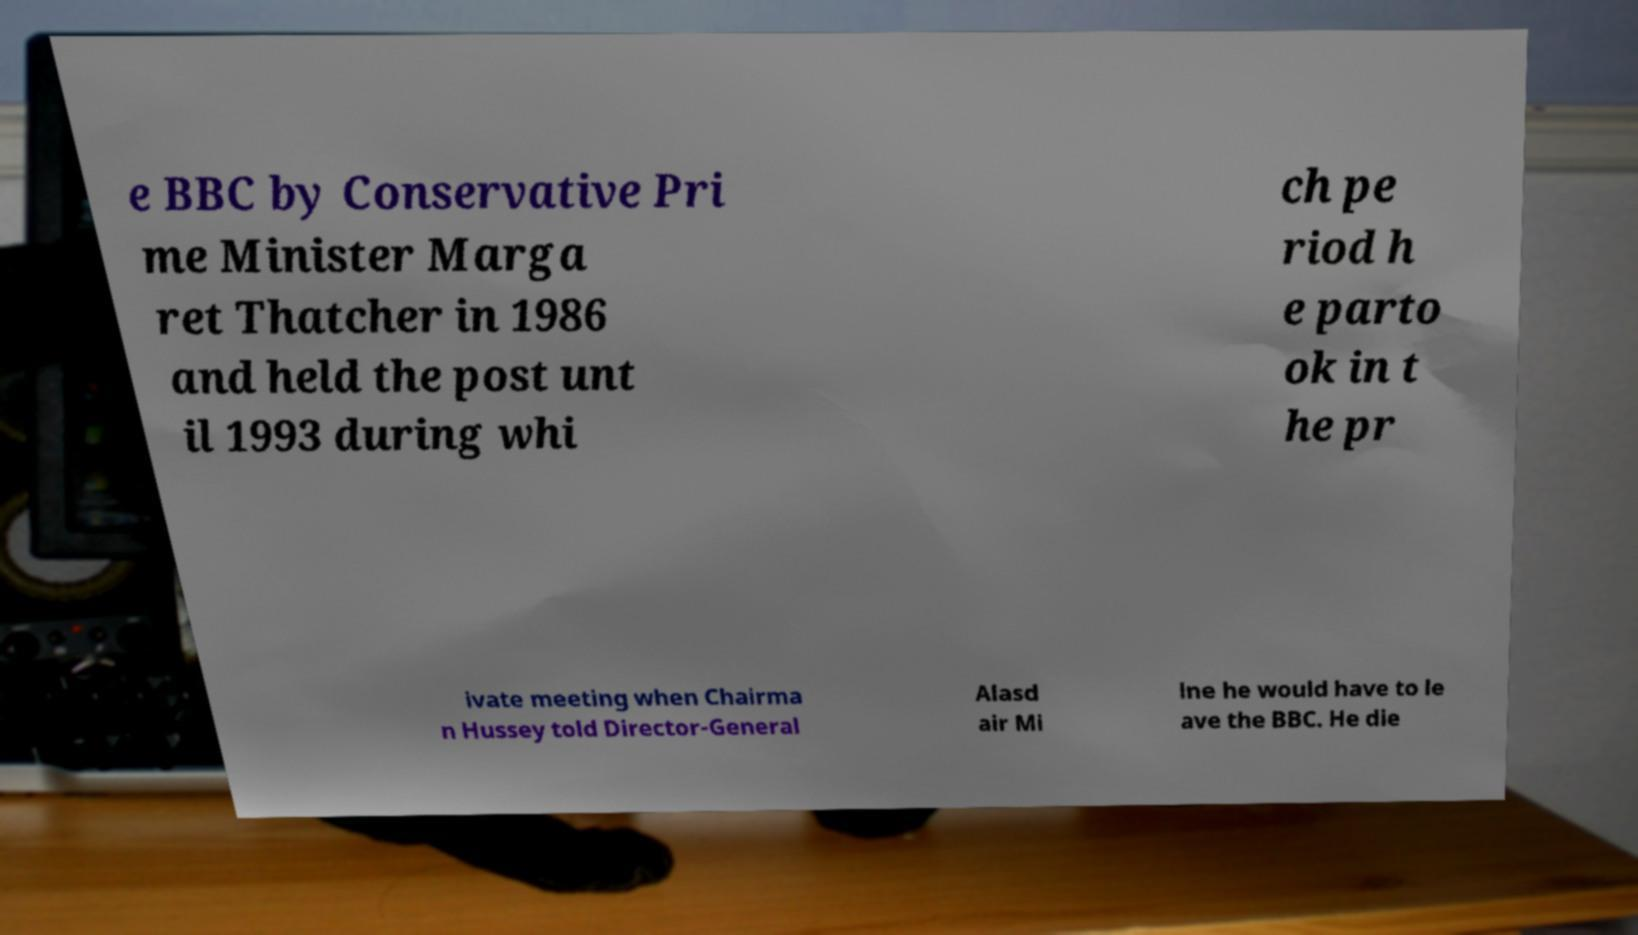Can you accurately transcribe the text from the provided image for me? e BBC by Conservative Pri me Minister Marga ret Thatcher in 1986 and held the post unt il 1993 during whi ch pe riod h e parto ok in t he pr ivate meeting when Chairma n Hussey told Director-General Alasd air Mi lne he would have to le ave the BBC. He die 